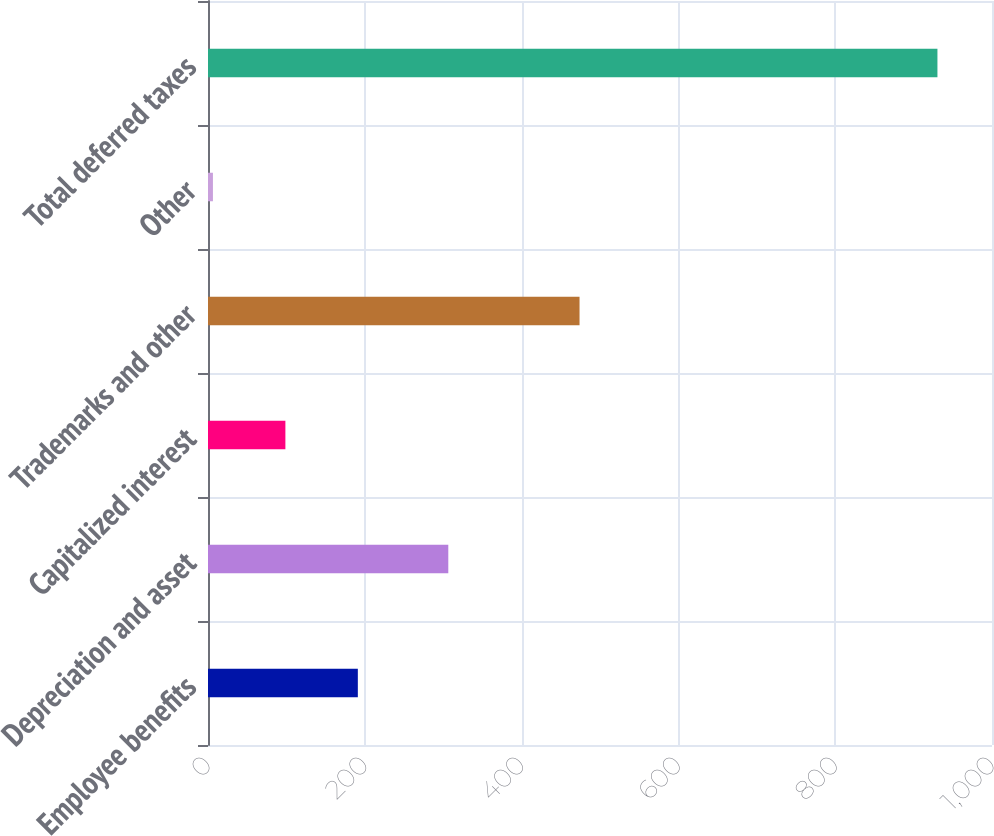Convert chart. <chart><loc_0><loc_0><loc_500><loc_500><bar_chart><fcel>Employee benefits<fcel>Depreciation and asset<fcel>Capitalized interest<fcel>Trademarks and other<fcel>Other<fcel>Total deferred taxes<nl><fcel>191.12<fcel>306.5<fcel>98.71<fcel>473.9<fcel>6.3<fcel>930.4<nl></chart> 